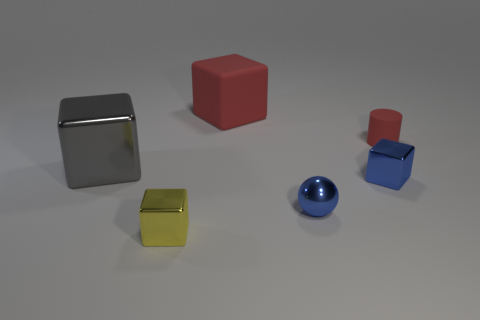Add 1 tiny yellow cubes. How many objects exist? 7 Subtract all spheres. How many objects are left? 5 Subtract all big cyan balls. Subtract all blue things. How many objects are left? 4 Add 6 small rubber things. How many small rubber things are left? 7 Add 5 red things. How many red things exist? 7 Subtract 0 green blocks. How many objects are left? 6 